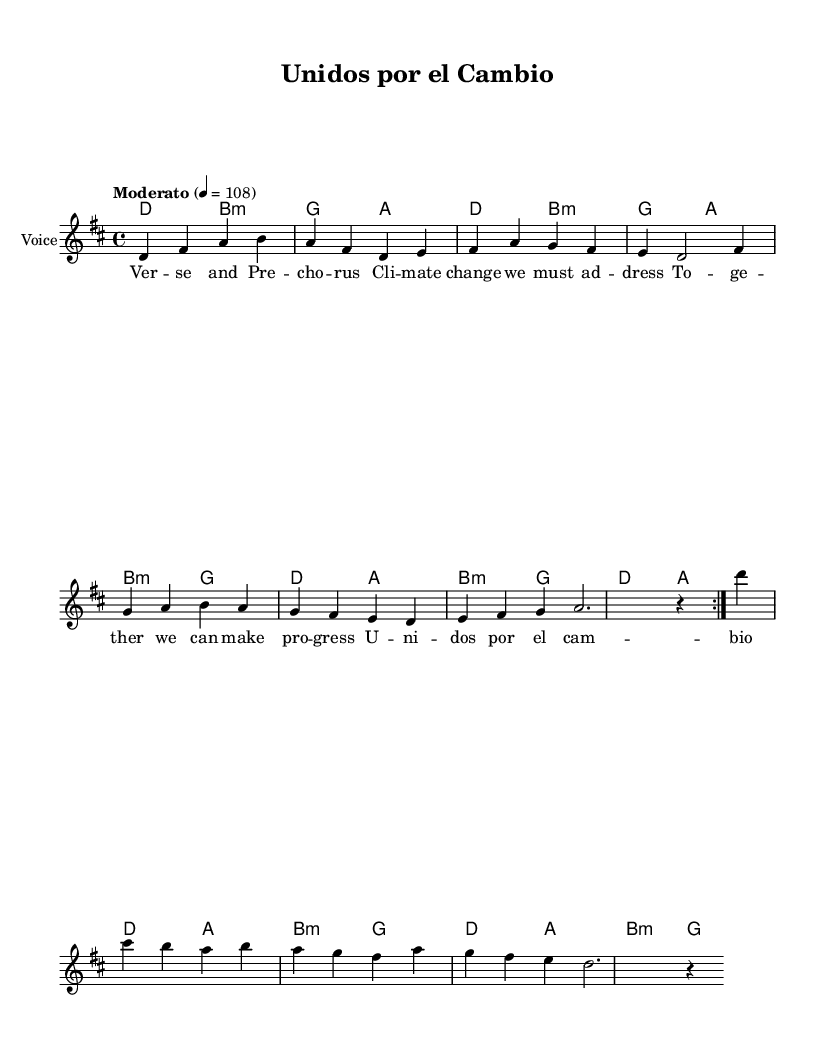What is the key signature of this music? The key signature is indicated at the beginning of the staff, showing two sharps, which means it is in D major.
Answer: D major What is the time signature of this music? The time signature appears at the beginning and is written as 4/4, indicating four beats per measure with a quarter note getting one beat.
Answer: 4/4 What is the tempo marking for this piece? The tempo marking is provided in the score and instructs a moderate speed, specifically indicating a metronome marking of 108 beats per minute.
Answer: Moderato 4 = 108 How many verses are present in the lyrics? By inspecting the lyrics section, there is one complete verse provided, including multiple lines, confirming it is a singular verse.
Answer: 1 What is the thematic focus of the lyrics? Analyzing the lyrics, they emphasize unity and the need to address global issues, particularly climate change, indicating a socially conscious theme.
Answer: Socially conscious How many times is the main melody repeated? The main melody is indicated with a repeat sign that specifies it should be played twice before moving to the next section.
Answer: 2 What instrument is indicated for the melody in this score? The instrument name on the staff clearly states "Voice", indicating that the melody is intended for vocal performance.
Answer: Voice 